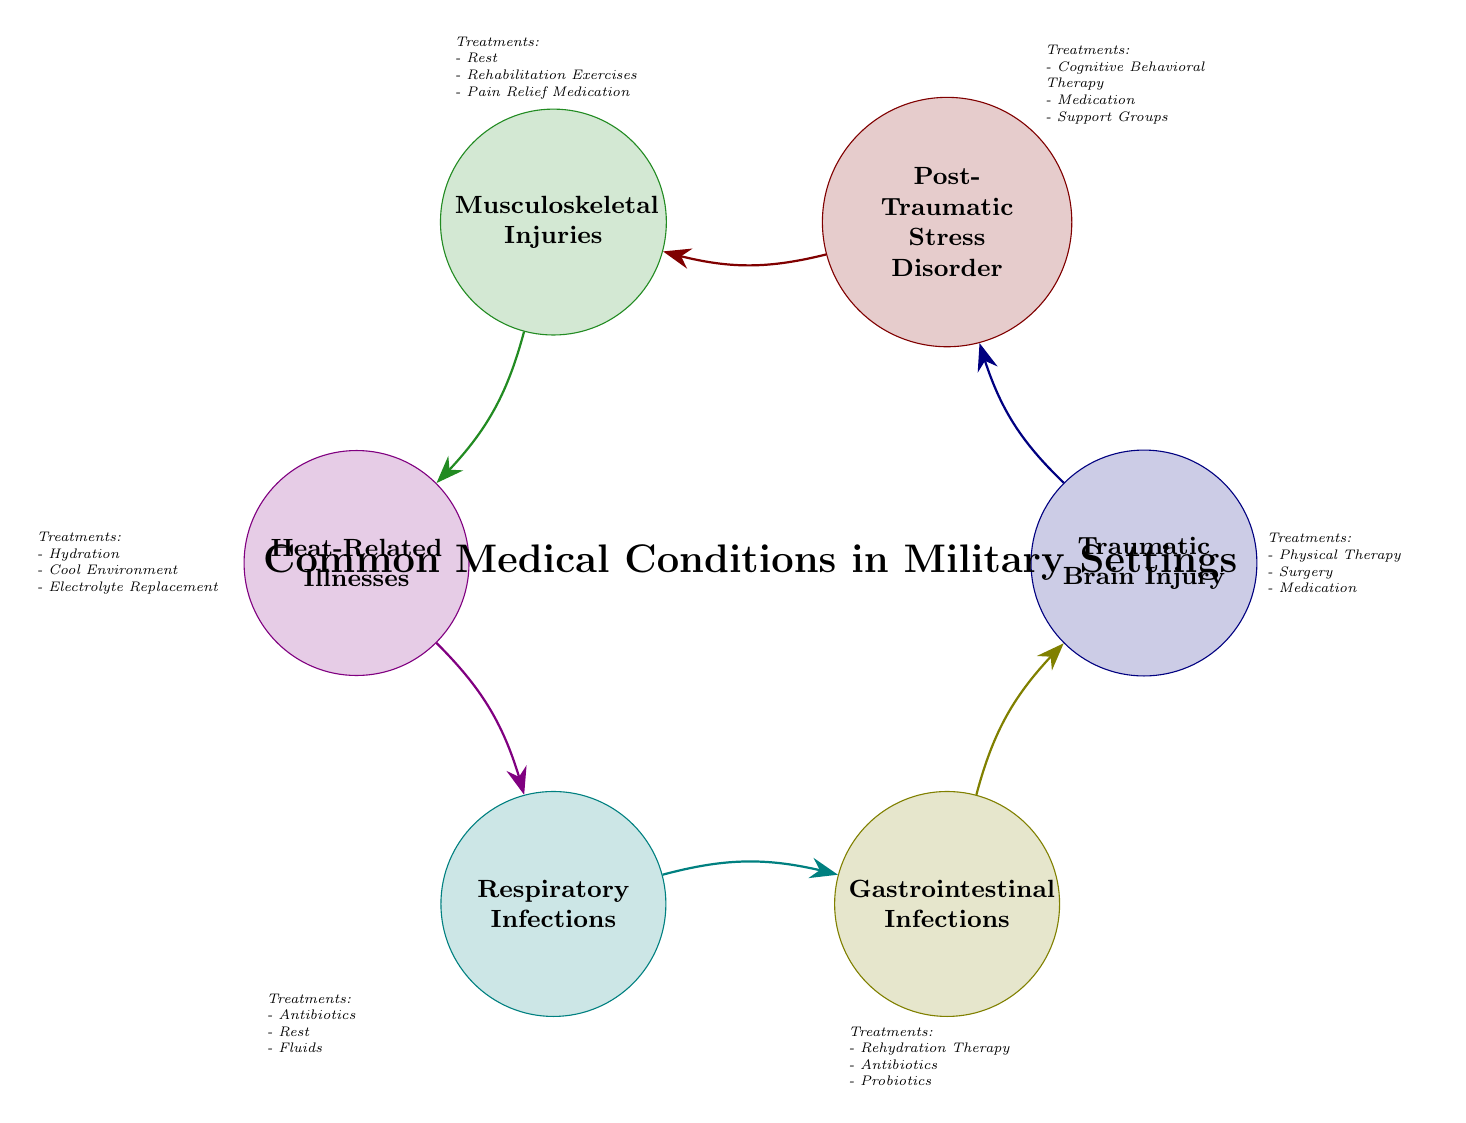What is the total number of nodes in the diagram? The diagram has 6 nodes: Traumatic Brain Injury, Post-Traumatic Stress Disorder, Musculoskeletal Injuries, Heat-Related Illnesses, Respiratory Infections, and Gastrointestinal Infections.
Answer: 6 Which medical condition is linked to Post-Traumatic Stress Disorder? In the diagram, Post-Traumatic Stress Disorder is directly linked to Musculoskeletal Injuries.
Answer: Musculoskeletal Injuries What is a treatment option for Gastrointestinal Infections? The treatments listed for Gastrointestinal Infections are Rehydration Therapy, Antibiotics, and Probiotics. Therefore, any of these can be an answer.
Answer: Rehydration Therapy How many treatment options are listed for Heat-Related Illnesses? The treatments for Heat-Related Illnesses include Hydration, Cool Environment, and Electrolyte Replacement. This gives a total of 3 treatment options.
Answer: 3 Which two medical conditions are directly connected in the sequence following Respiratory Infections? The sequence continues with Gastrointestinal Infections leading back to Traumatic Brain Injury.
Answer: Gastrointestinal Infections, Traumatic Brain Injury What is the first node in the flow of conditions that leads to Post-Traumatic Stress Disorder? The flow starts with Traumatic Brain Injury, which leads into Post-Traumatic Stress Disorder.
Answer: Traumatic Brain Injury What treatment is common for Traumatic Brain Injury and Musculoskeletal Injuries? Both conditions offer medication as a treatment option for their respective conditions.
Answer: Medication Which condition has the most treatment options listed in the diagram? By evaluating the treatments, both Traumatic Brain Injury and Post-Traumatic Stress Disorder have 3 treatment options listed, while others have fewer. Therefore, the answer will include one of these conditions.
Answer: Traumatic Brain Injury or Post-Traumatic Stress Disorder 